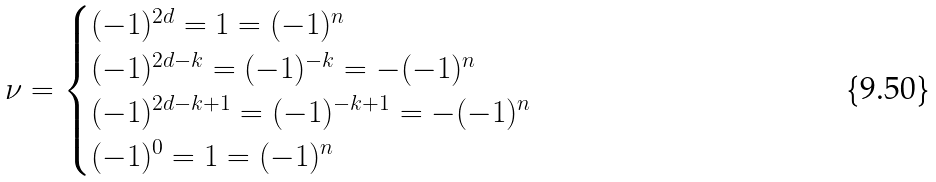Convert formula to latex. <formula><loc_0><loc_0><loc_500><loc_500>\nu = \begin{cases} ( - 1 ) ^ { 2 d } = 1 = ( - 1 ) ^ { n } & \\ ( - 1 ) ^ { 2 d - k } = ( - 1 ) ^ { - k } = - ( - 1 ) ^ { n } & \\ ( - 1 ) ^ { 2 d - k + 1 } = ( - 1 ) ^ { - k + 1 } = - ( - 1 ) ^ { n } & \\ ( - 1 ) ^ { 0 } = 1 = ( - 1 ) ^ { n } & \\ \end{cases}</formula> 